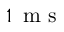<formula> <loc_0><loc_0><loc_500><loc_500>1 \, m s</formula> 